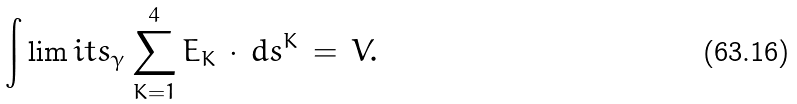Convert formula to latex. <formula><loc_0><loc_0><loc_500><loc_500>\int \lim i t s _ { \gamma } \sum _ { K = 1 } ^ { 4 } E _ { K } \, \cdot \, d s ^ { K } \, = \, V .</formula> 